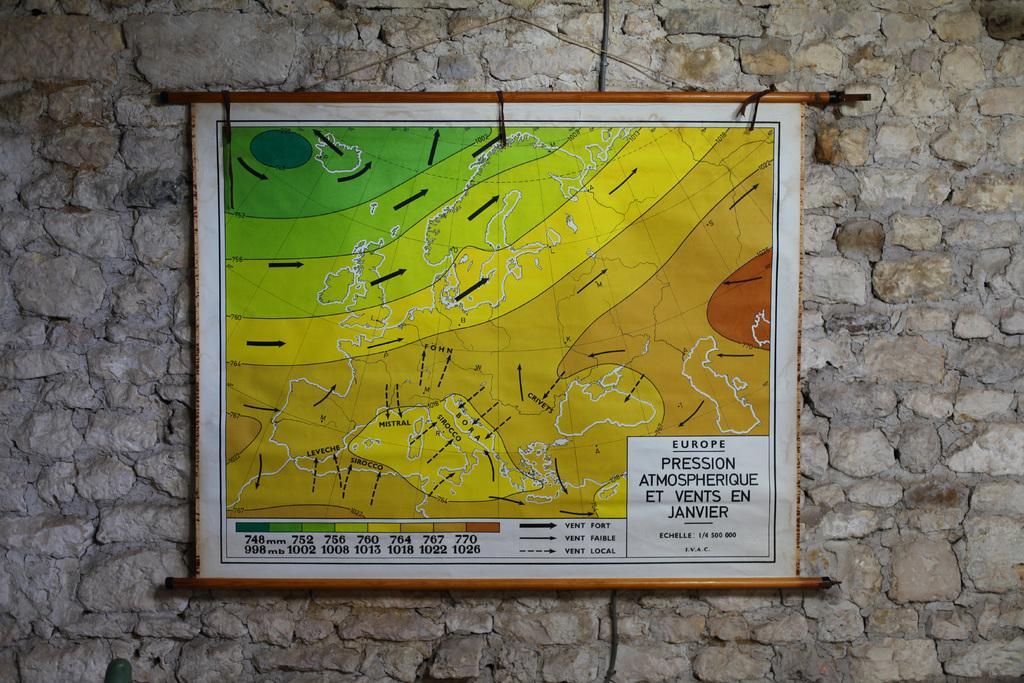Please provide a concise description of this image. In the center of the image we can see a board is present on the stone wall. On board we can see the direction and text. 